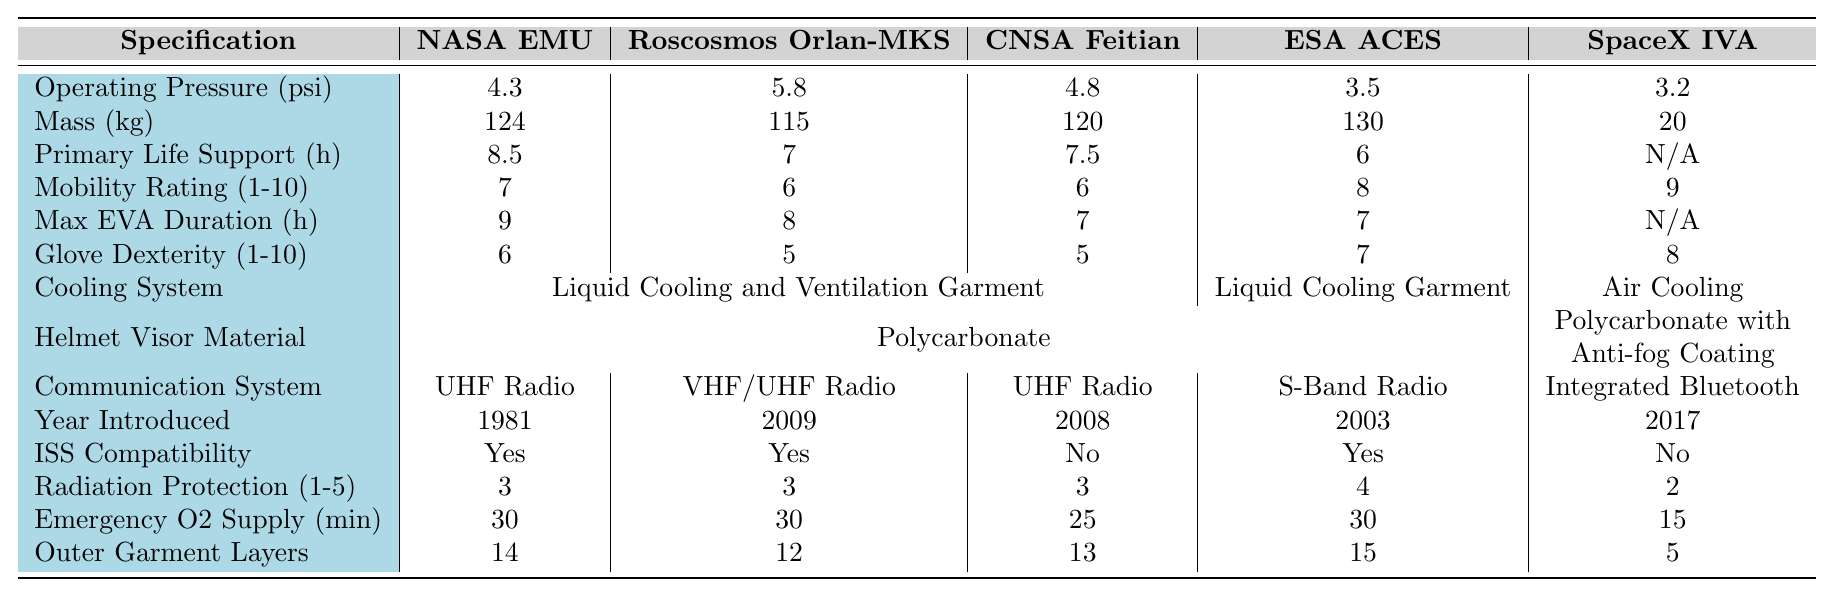What is the operating pressure of the NASA EMU suit? The NASA EMU suit has an operating pressure of 4.3 psi, as listed in the table under the "Operating Pressure (psi)" column.
Answer: 4.3 psi Which space suit has the highest mobility rating? The SpaceX IVA Suit has the highest mobility rating of 9, shown in the "Mobility Rating (1-10)" column.
Answer: SpaceX IVA Suit What is the average mass of the space suits listed? The masses of the suits are 124 kg, 115 kg, 120 kg, 130 kg, and 20 kg. The sum of these values is 124 + 115 + 120 + 130 + 20 = 609 kg. Dividing by 5 gives an average mass of 609 / 5 = 121.8 kg.
Answer: 121.8 kg Is the CNSA Feitian suit compatible with the ISS? The CNSA Feitian suit is listed as "No" under the "ISS Compatibility" column, indicating it is not compatible.
Answer: No How many layers does the ESA Advanced Crew Escape Suit have in its outer garment? The ESA Advanced Crew Escape Suit has 15 layers in its outer garment, as specified in the "Number of Layers in Outer Garment" column.
Answer: 15 layers What percentage of the suits have a primary life support duration shorter than 8 hours? The suits with a primary life support duration are 8.5, 7, 7.5, 6, and N/A hours. Excluding N/A, 3 out of 4 suits have durations shorter than 8 hours. 3 suits out of 5 total suits is 60%.
Answer: 60% Which suit has the highest glove dexterity rating? The SpaceX IVA Suit has the highest glove dexterity rating of 8, according to the "Glove Dexterity Rating (1-10)" column.
Answer: SpaceX IVA Suit What is the difference in maximum EVA duration between the NASA EMU and SpaceX IVA suits? The NASA EMU has a maximum EVA duration of 9 hours and the SpaceX IVA has "N/A". Ignoring "N/A", the difference between 9 hours and the maximum for the other suits can be seen. However, for accurate comparison, since SpaceX's is not applicable, we conclude the duration difference is irrelevant.
Answer: N/A Which space suits use air cooling as part of their cooling system? The only suit using air cooling is the SpaceX IVA suit, while the others use liquid cooling systems, as per the "Cooling System Type" column.
Answer: SpaceX IVA Suit How many space suits have a maximum EVA duration of 7 hours or less? The maximum EVA durations are 9, 8, 7, 7, and "N/A". The suits with 7 hours or less are the CNSA Feitian and the SpaceX IVA Suit, totaling 2 suits.
Answer: 2 suits What is the total emergency oxygen supply duration for a NASA EMU suit? The NASA EMU suit has an emergency oxygen supply duration of 30 minutes, as indicated in the "Emergency Oxygen Supply Duration (minutes)" column.
Answer: 30 minutes 